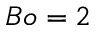<formula> <loc_0><loc_0><loc_500><loc_500>B o = 2</formula> 